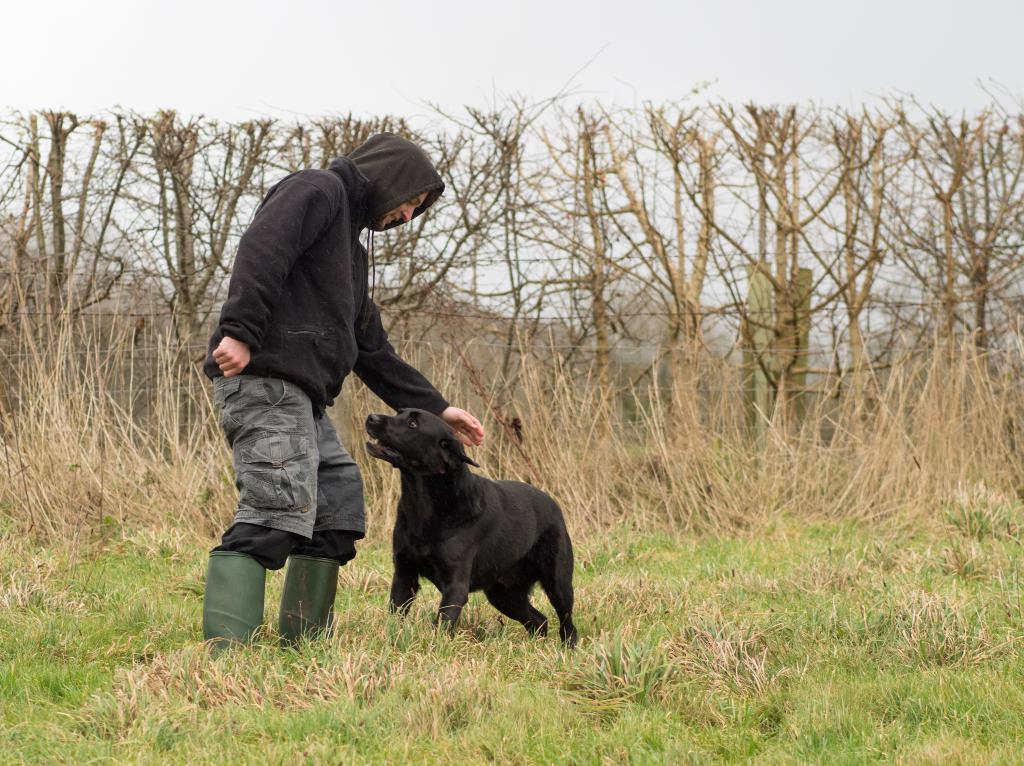What is present in the image? There is a man and a dog in the image. What type of living organism can be seen in the image besides the man? There is a dog visible in the image. What can be seen in the background of the image? There are trees visible in the image. What type of blood can be seen on the man's clothes in the image? There is no blood visible on the man's clothes in the image. How many geese are present in the image? There are no geese present in the image. What type of tank can be seen in the image? There is no tank present in the image. 